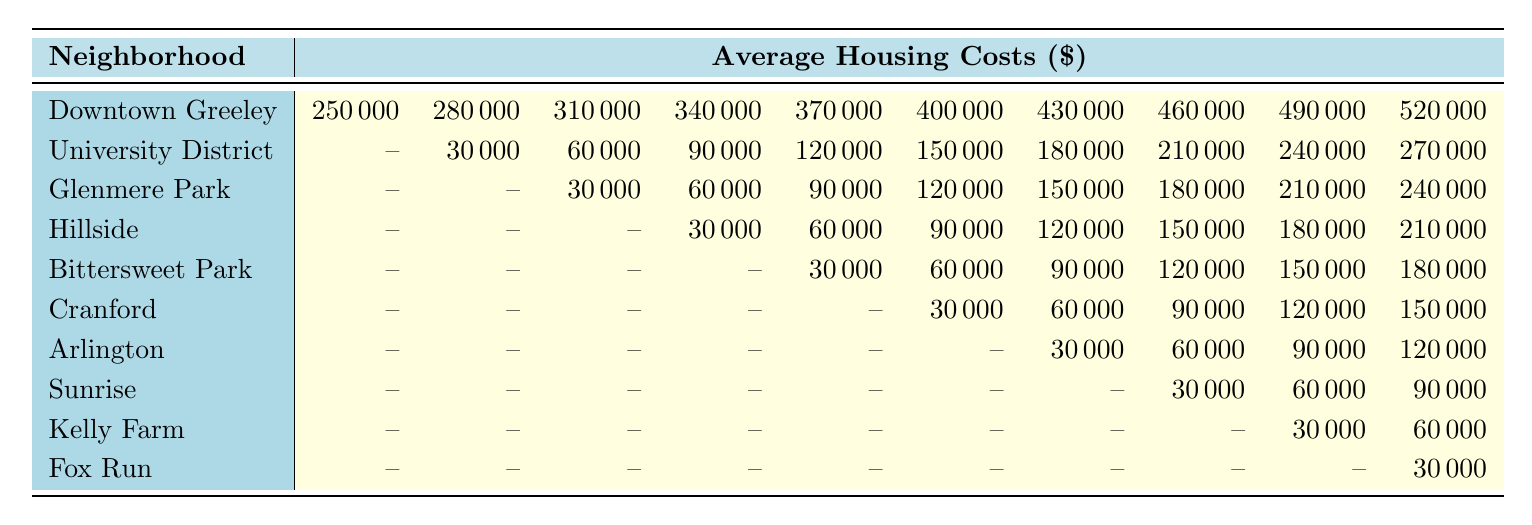What is the average housing cost in Downtown Greeley? The table shows that the average housing cost in Downtown Greeley is $250,000 as listed directly in the corresponding row for that neighborhood.
Answer: $250,000 Which neighborhood has the highest average housing cost? According to the table, Downtown Greeley has the highest average housing cost of $250,000 compared to the other neighborhoods listed.
Answer: Downtown Greeley What is the average housing cost in the University District? The University District has a range of housing costs starting from $30,000 to $270,000, with the specific average housing cost of $150,000 detailed in the table.
Answer: $150,000 Is there any neighborhood with an average housing cost of $0? Yes, multiple neighborhoods such as University District, Glenmere Park, Hillside, Bittersweet Park, Cranford, Arlington, Sunrise, Kelly Farm, and Fox Run show an average cost of $0 in their lower price ranges.
Answer: Yes What is the average cost of housing in Fox Run compared to Kelly Farm? Fox Run has an average cost of $30,000 while Kelly Farm has a higher average of $30,000; thus, they are equal when comparing their average costs directly.
Answer: Equal Which neighborhood has the second lowest average housing cost? The Glenmere Park, with a starting point of $30,000 in average housing costs, is listed next after the neighborhoods with an average of $0.
Answer: Glenmere Park How much higher is the highest housing cost in Downtown Greeley compared to the highest in Fox Run? The highest housing cost in Downtown Greeley is $520,000 and in Fox Run is $30,000. The difference is $520,000 - $30,000 = $490,000.
Answer: $490,000 What is the total average housing cost for the University District? To find the total average housing cost for the University District, add all provided values: 0 + 30,000 + 60,000 + 90,000 + 120,000 + 150,000 + 180,000 + 210,000 + 240,000 + 270,000 = 1,650,000, then divide by the number of values, which is 10, yielding an average of $165,000.
Answer: $165,000 Which neighborhood shows a gradual increase in average housing costs as you move down the rows? The neighborhoods from University District to Downtown Greeley show a gradual increase in average housing costs, which increases consistently across the price points in the table.
Answer: Yes What is the difference in average housing costs between Bittersweet Park and Hillside? Bittersweet Park shows an average cost beginning from $30,000 going to $180,000, whereas Hillside starts from $30,000 up to $210,000. The difference hence will be $210,000 - $180,000 = $30,000.
Answer: $30,000 